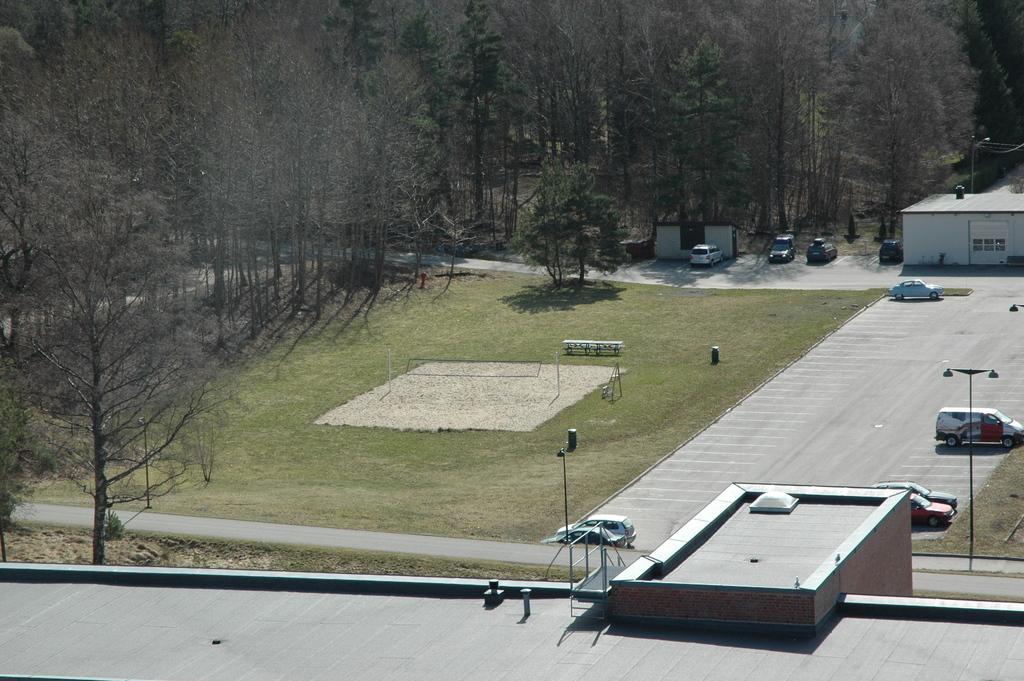Can you describe this image briefly? In the foreground there is a building. On the left and in the background there are trees. Towards right there are vehicles, building, path, glass, benches and various objects. 